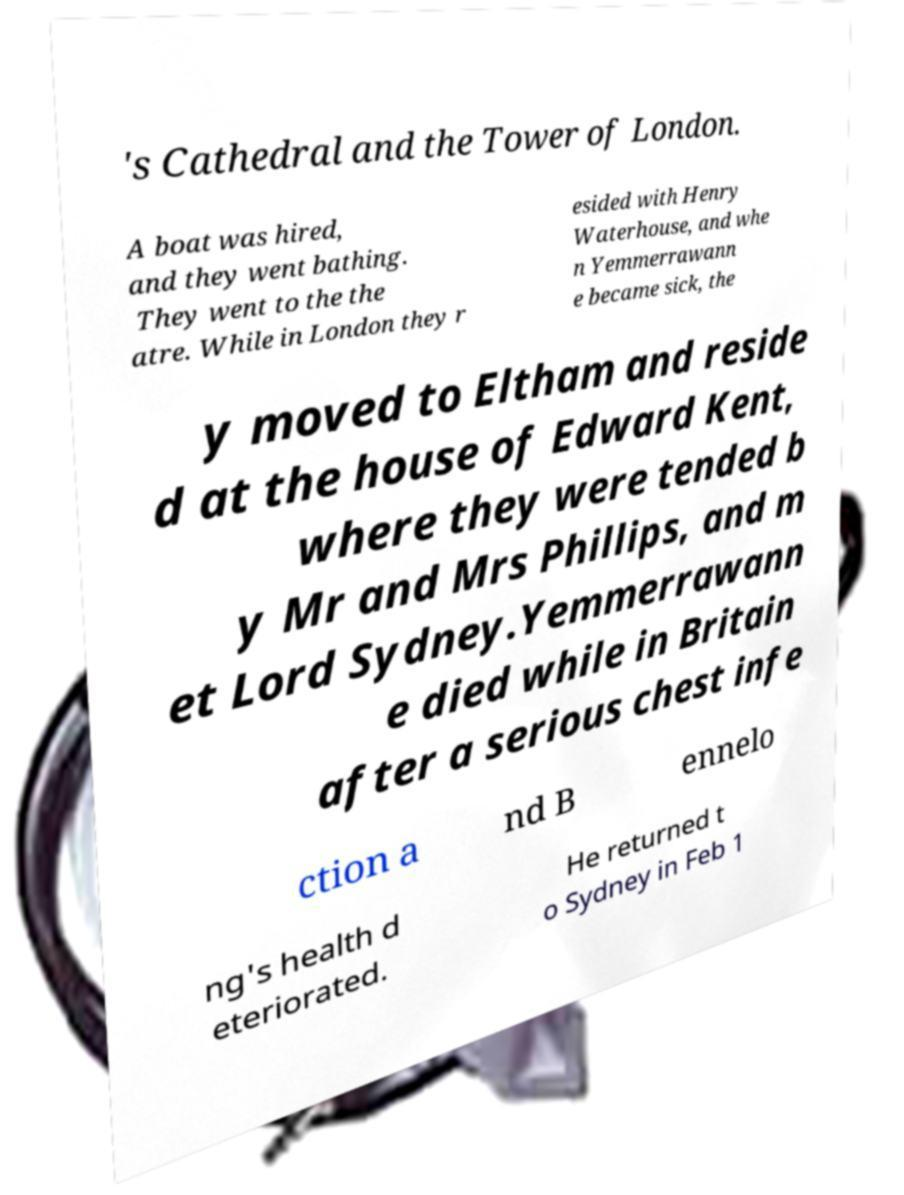Could you extract and type out the text from this image? 's Cathedral and the Tower of London. A boat was hired, and they went bathing. They went to the the atre. While in London they r esided with Henry Waterhouse, and whe n Yemmerrawann e became sick, the y moved to Eltham and reside d at the house of Edward Kent, where they were tended b y Mr and Mrs Phillips, and m et Lord Sydney.Yemmerrawann e died while in Britain after a serious chest infe ction a nd B ennelo ng's health d eteriorated. He returned t o Sydney in Feb 1 